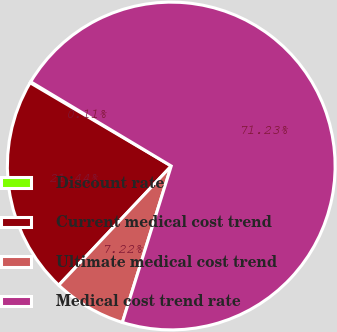Convert chart to OTSL. <chart><loc_0><loc_0><loc_500><loc_500><pie_chart><fcel>Discount rate<fcel>Current medical cost trend<fcel>Ultimate medical cost trend<fcel>Medical cost trend rate<nl><fcel>0.11%<fcel>21.44%<fcel>7.22%<fcel>71.22%<nl></chart> 